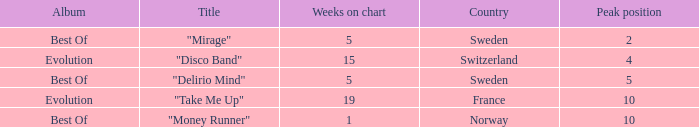What is the most weeks on chart when the peak position is less than 5 and from sweden? 5.0. 